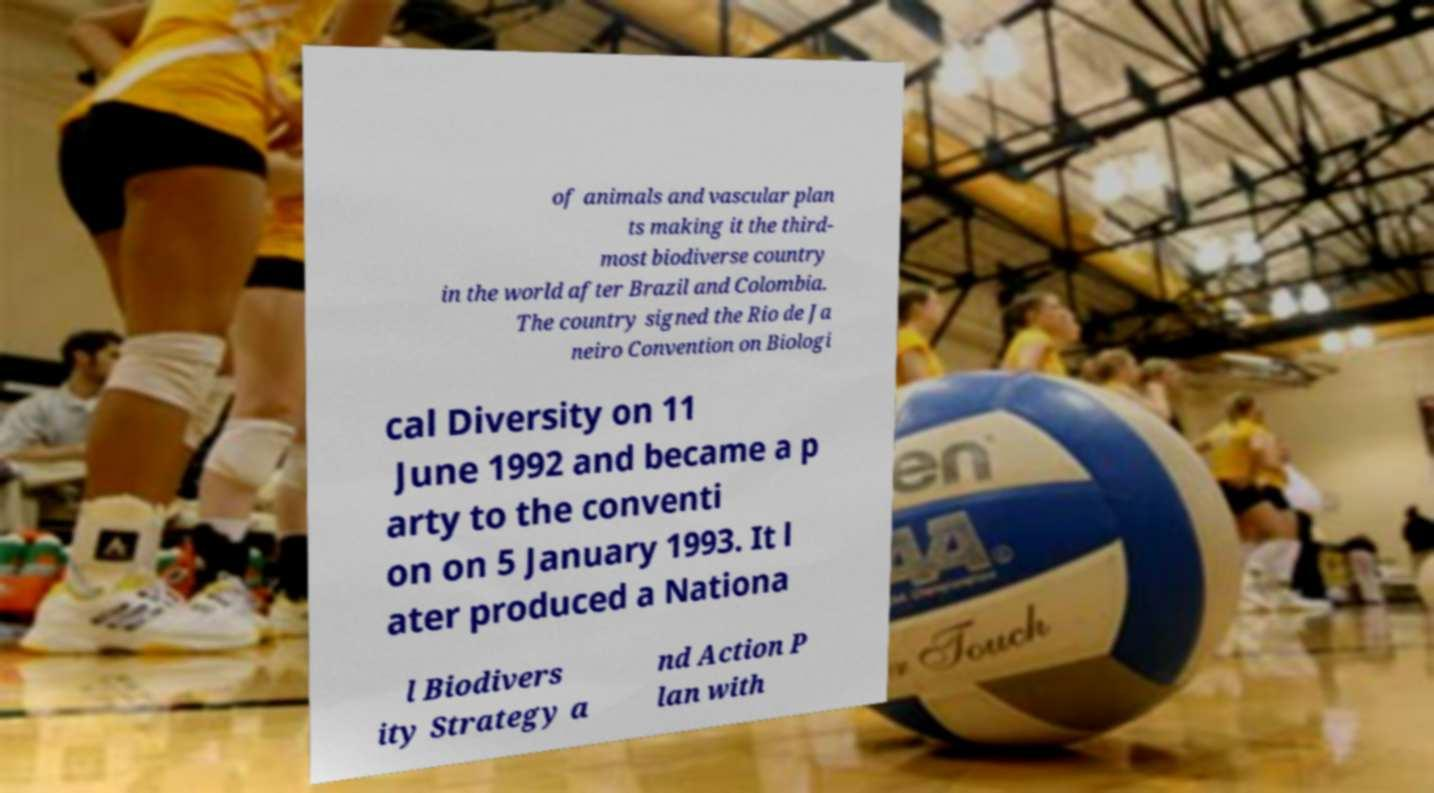I need the written content from this picture converted into text. Can you do that? of animals and vascular plan ts making it the third- most biodiverse country in the world after Brazil and Colombia. The country signed the Rio de Ja neiro Convention on Biologi cal Diversity on 11 June 1992 and became a p arty to the conventi on on 5 January 1993. It l ater produced a Nationa l Biodivers ity Strategy a nd Action P lan with 